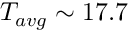<formula> <loc_0><loc_0><loc_500><loc_500>T _ { a v g } \sim 1 7 . 7</formula> 